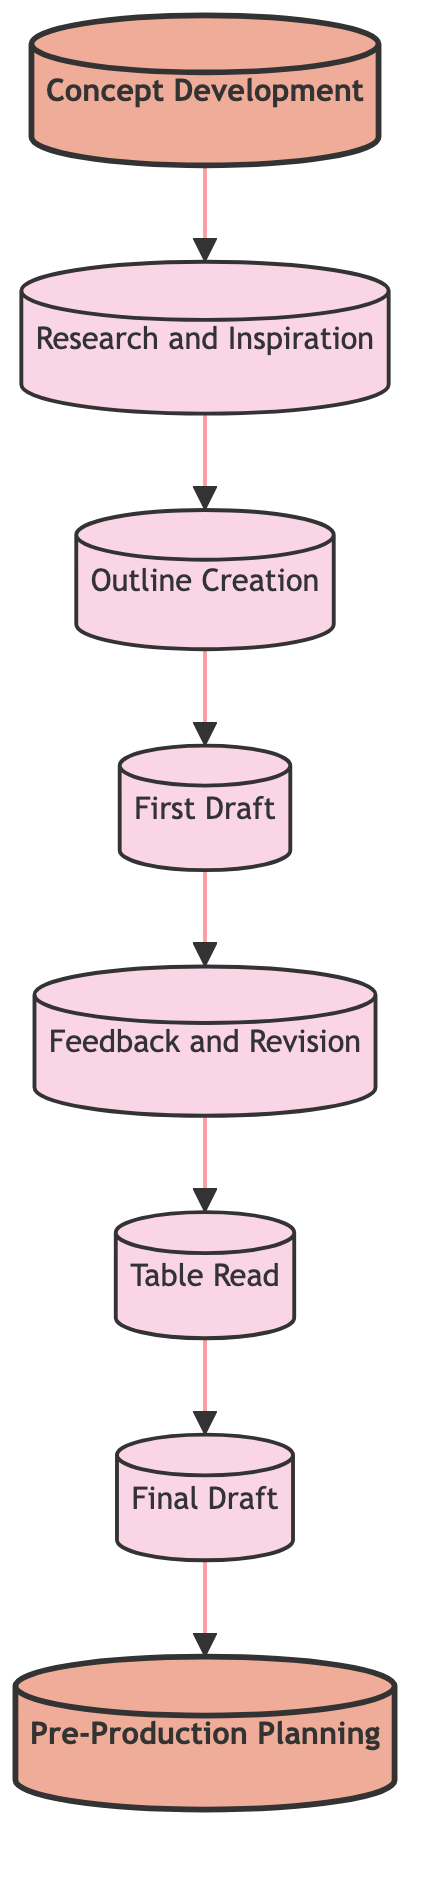What is the starting point of the scriptwriting process? The diagram indicates that the first step is "Concept Development."
Answer: Concept Development What is the final step in the process? According to the flow chart, the last step is "Pre-Production Planning."
Answer: Pre-Production Planning How many total steps are there in the scriptwriting process? By counting the nodes in the diagram, there are eight distinct steps.
Answer: 8 Which step follows "Feedback and Revision"? The arrow from "Feedback and Revision" points to the next step, which is "Table Read."
Answer: Table Read What is the immediate predecessor of "Final Draft"? The diagram shows that "Final Draft" comes after "Table Read."
Answer: Table Read What action is taken during the "First Draft"? The description for "First Draft" states to write the first draft of the screenplay.
Answer: Write the first draft How does "Research and Inspiration" relate to "Outline Creation"? "Research and Inspiration" is the step that directly precedes "Outline Creation" in the flow.
Answer: Directly precedes What happens after "Table Read"? The diagram indicates that after "Table Read," the process moves to "Final Draft."
Answer: Final Draft What is being generated in the first step? In the "Concept Development" step, ideas for the film are generated and refined.
Answer: Ideas for the film 